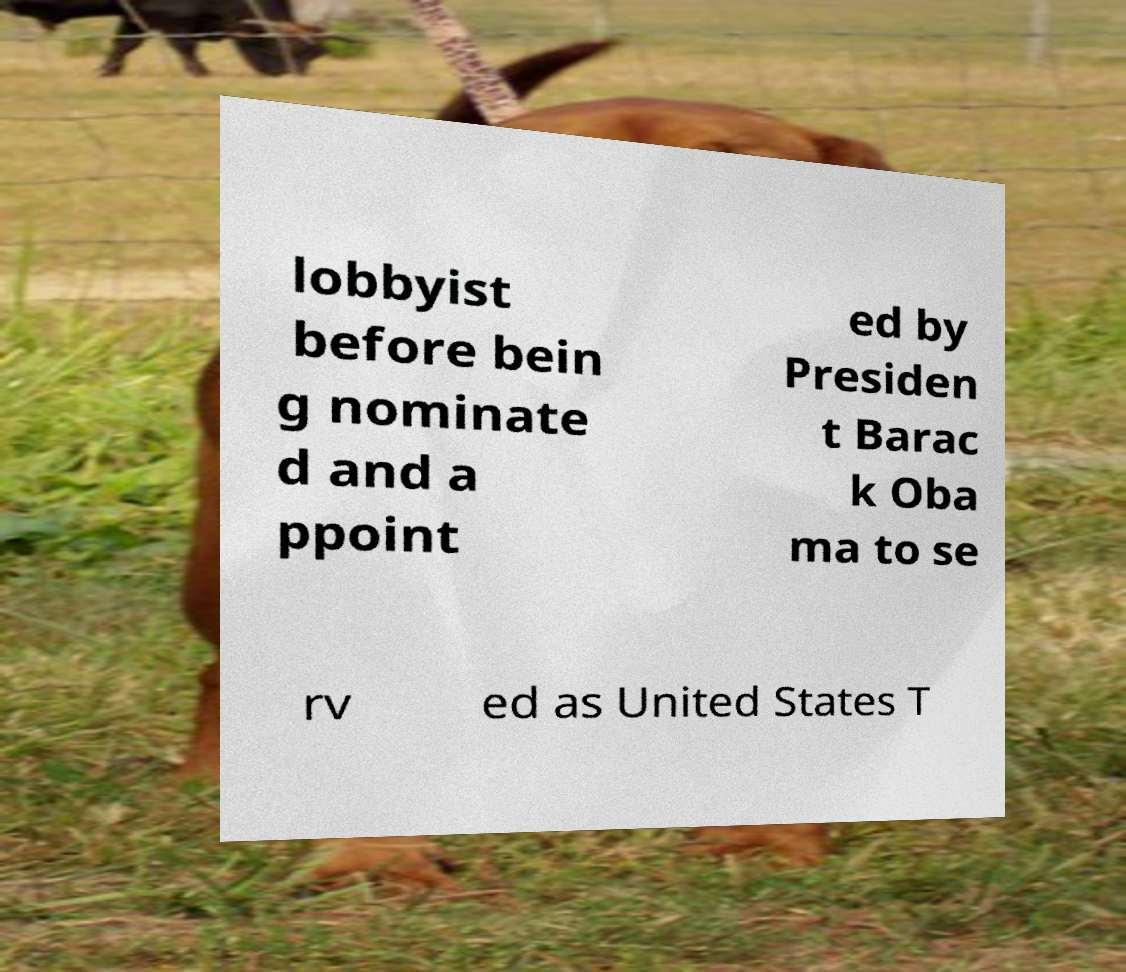Could you assist in decoding the text presented in this image and type it out clearly? lobbyist before bein g nominate d and a ppoint ed by Presiden t Barac k Oba ma to se rv ed as United States T 